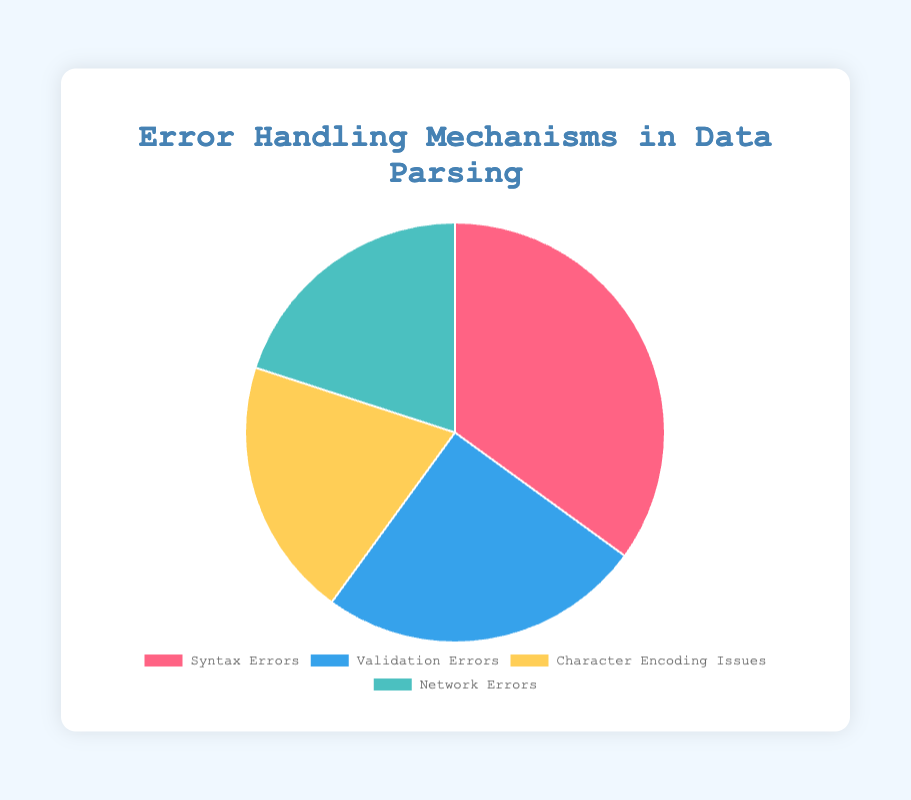What percentage of issues are related to Syntax Errors? The pie chart shows a section labeled "Syntax Errors" with a percentage value. This percentage indicates the portion of total issues attributed to syntax errors.
Answer: 35% Which error type has the least occurrence? By looking at the pie chart, the sections labeled "Character Encoding Issues" and "Network Errors" each represent smaller portions compared to "Syntax Errors" and "Validation Errors". Both have the same percentage but are the least.
Answer: Character Encoding Issues and Network Errors How do the combined occurrences of Character Encoding Issues and Network Errors compare to Syntax Errors? Add the percentages of Character Encoding Issues (20%) and Network Errors (20%), and compare the result with the percentage for Syntax Errors (35%). 20% + 20% = 40%, which is greater than 35%.
Answer: Greater What is the total percentage of issues that are not related to Validation Errors? Subtract the percentage of Validation Errors (25%) from the total (100%). 100% - 25% = 75%.
Answer: 75% Are Syntax Errors more frequent than Validation Errors? Compare the percentage values of Syntax Errors (35%) and Validation Errors (25%) as depicted in the chart. 35% is greater than 25%.
Answer: Yes Which color section represents Validation Errors? The pie chart uses distinct colors for different sections. Identify the color used for the section labeled "Validation Errors".
Answer: Blue How much more frequent are Syntax Errors compared to Character Encoding Issues? Subtract the percentage of Character Encoding Issues (20%) from the percentage of Syntax Errors (35%). 35% - 20% = 15%.
Answer: 15% What is the combined percentage of Character Encoding Issues and Validation Errors? Add the percentages of Character Encoding Issues (20%) and Validation Errors (25%). 20% + 25% = 45%.
Answer: 45% Is there an equal percentage for any of the error types? Identify if any segments of the pie chart show the same percentage value. "Character Encoding Issues" and "Network Errors" both show a percentage of 20%.
Answer: Yes What portion of the total issues do the Network Errors comprise? The pie chart specifies the percentage for "Network Errors". Look at this segment to get the value.
Answer: 20% 